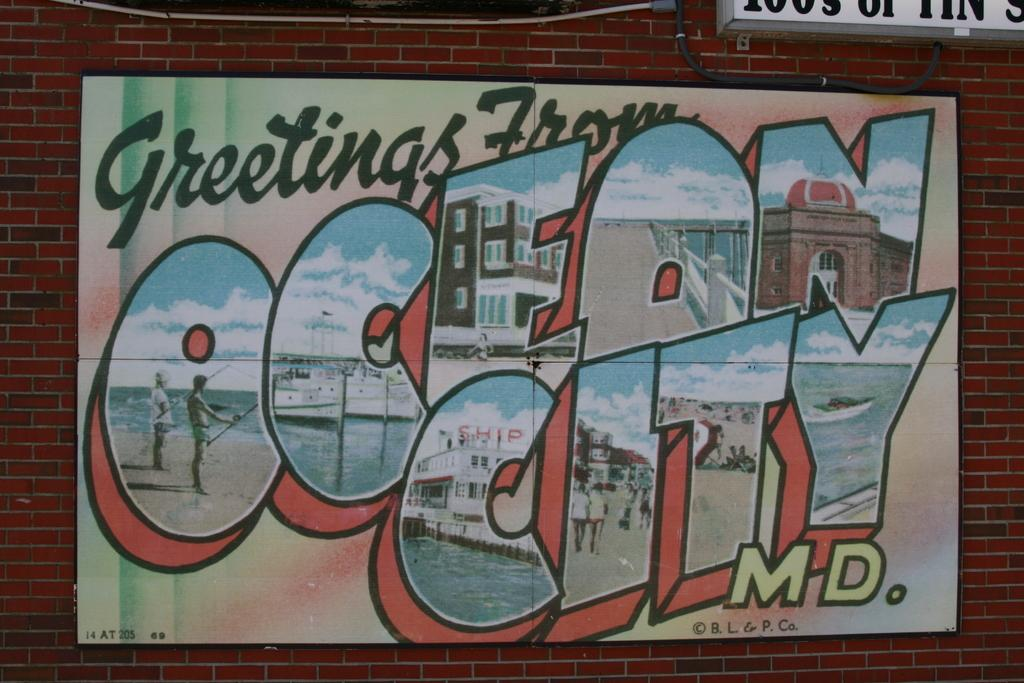<image>
Relay a brief, clear account of the picture shown. A building hosts a post card like advertisement for Ocean City Maryland. 